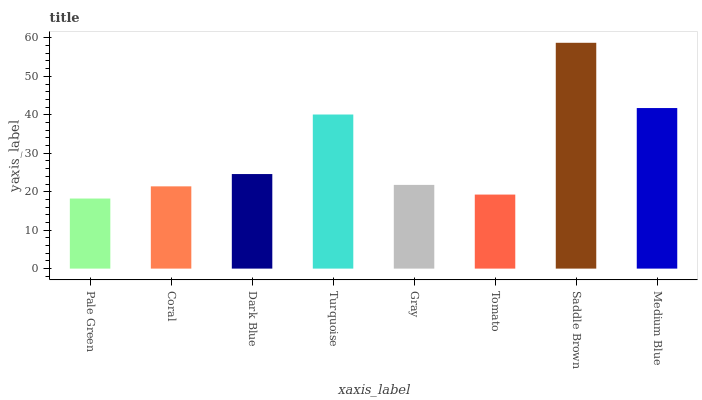Is Pale Green the minimum?
Answer yes or no. Yes. Is Saddle Brown the maximum?
Answer yes or no. Yes. Is Coral the minimum?
Answer yes or no. No. Is Coral the maximum?
Answer yes or no. No. Is Coral greater than Pale Green?
Answer yes or no. Yes. Is Pale Green less than Coral?
Answer yes or no. Yes. Is Pale Green greater than Coral?
Answer yes or no. No. Is Coral less than Pale Green?
Answer yes or no. No. Is Dark Blue the high median?
Answer yes or no. Yes. Is Gray the low median?
Answer yes or no. Yes. Is Turquoise the high median?
Answer yes or no. No. Is Pale Green the low median?
Answer yes or no. No. 